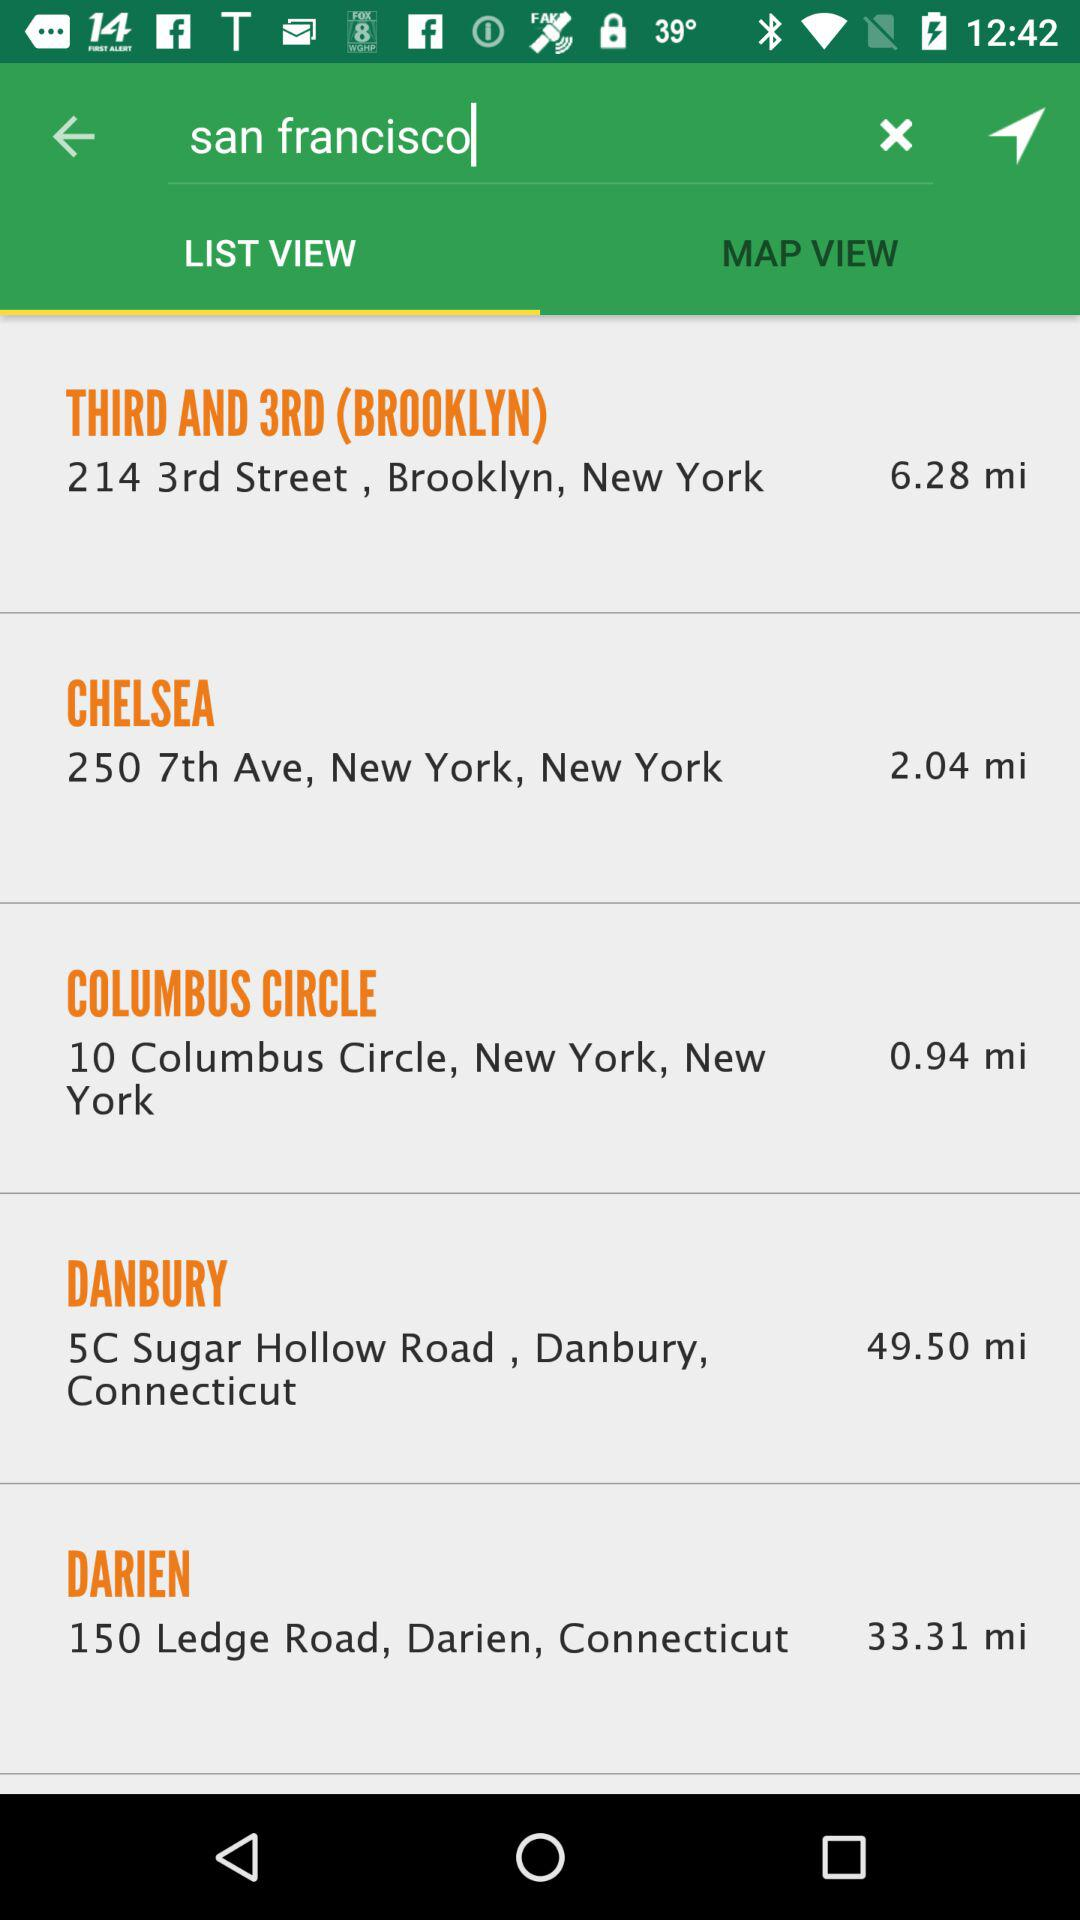What is the reach time for DANBURY?
When the provided information is insufficient, respond with <no answer>. <no answer> 